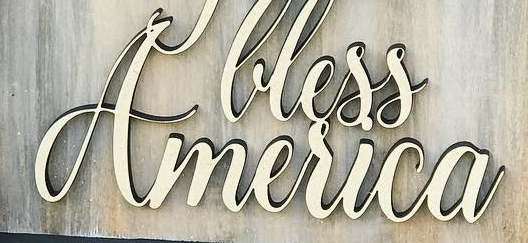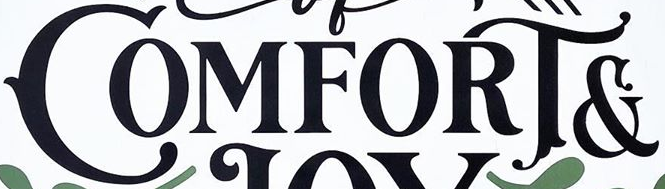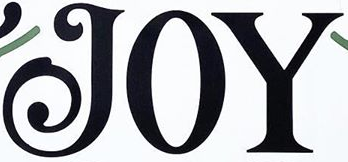What text appears in these images from left to right, separated by a semicolon? America; COMFORT&; JOY 